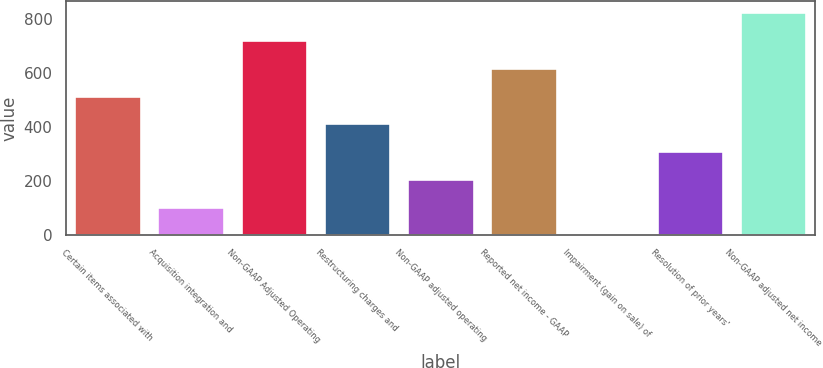Convert chart. <chart><loc_0><loc_0><loc_500><loc_500><bar_chart><fcel>Certain items associated with<fcel>Acquisition integration and<fcel>Non-GAAP Adjusted Operating<fcel>Restructuring charges and<fcel>Non-GAAP adjusted operating<fcel>Reported net income - GAAP<fcel>Impairment (gain on sale) of<fcel>Resolution of prior years'<fcel>Non-GAAP adjusted net income<nl><fcel>516.5<fcel>104.1<fcel>722.7<fcel>413.4<fcel>207.2<fcel>619.6<fcel>1<fcel>310.3<fcel>825.8<nl></chart> 